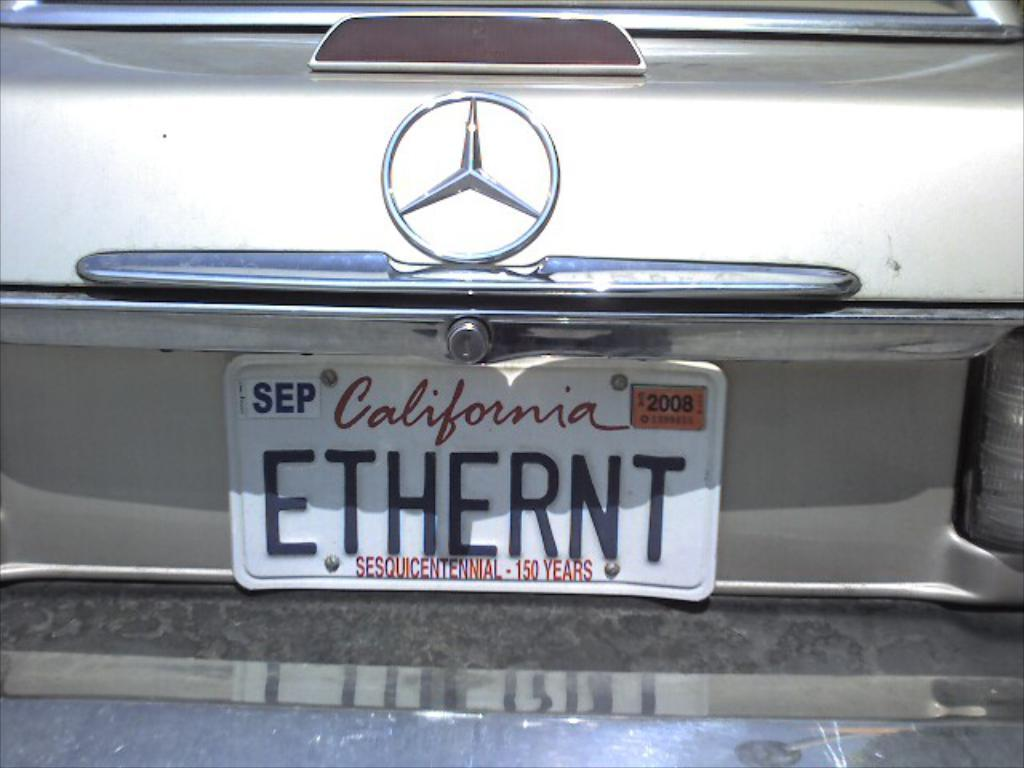<image>
Summarize the visual content of the image. A Mercedes has a California license plate that says ETHERNT. 